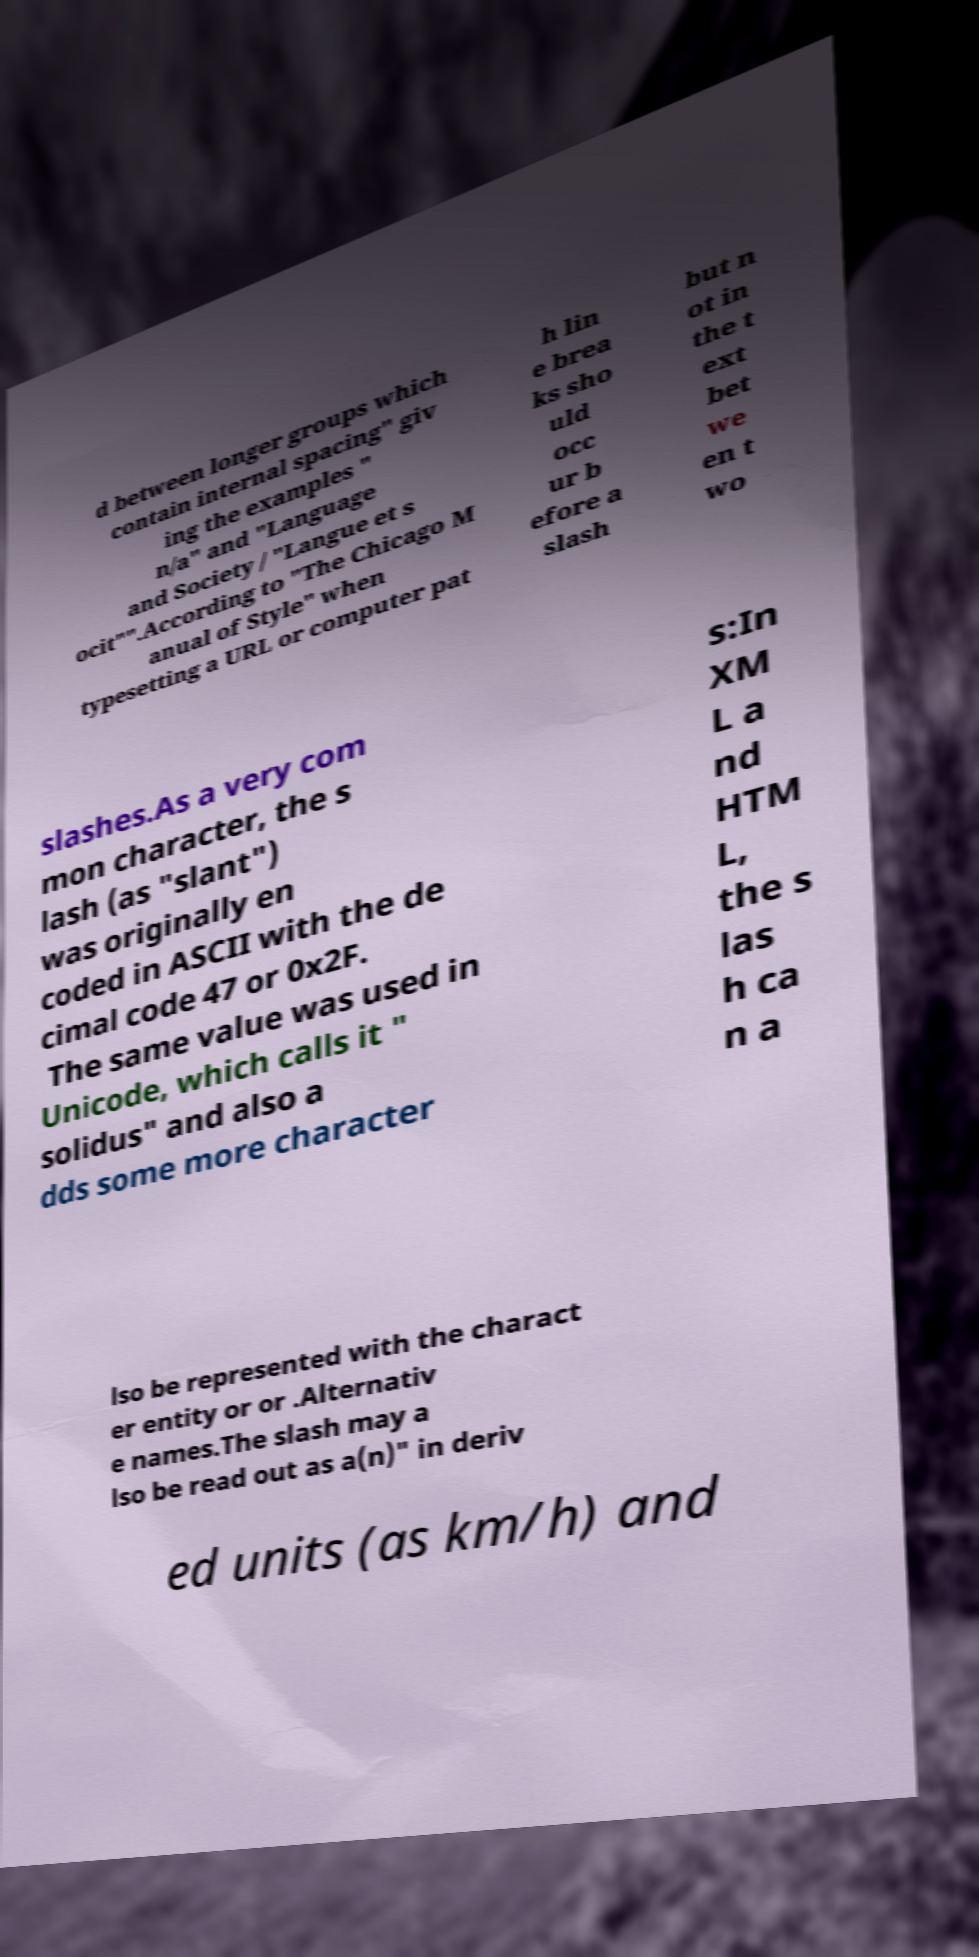Can you accurately transcribe the text from the provided image for me? d between longer groups which contain internal spacing" giv ing the examples " n/a" and "Language and Society / "Langue et s ocit"".According to "The Chicago M anual of Style" when typesetting a URL or computer pat h lin e brea ks sho uld occ ur b efore a slash but n ot in the t ext bet we en t wo slashes.As a very com mon character, the s lash (as "slant") was originally en coded in ASCII with the de cimal code 47 or 0x2F. The same value was used in Unicode, which calls it " solidus" and also a dds some more character s:In XM L a nd HTM L, the s las h ca n a lso be represented with the charact er entity or or .Alternativ e names.The slash may a lso be read out as a(n)" in deriv ed units (as km/h) and 